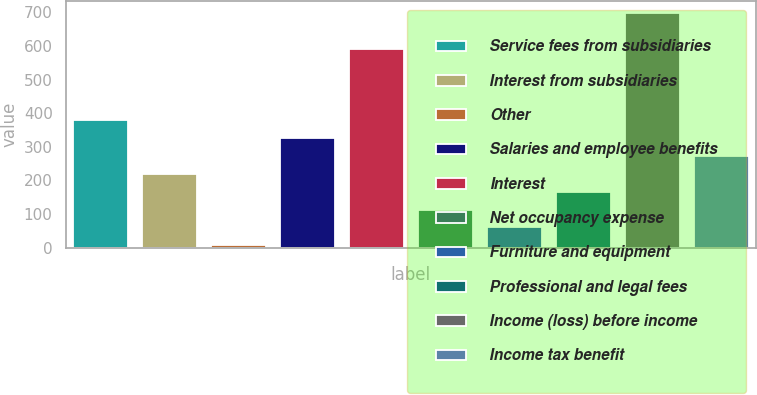Convert chart to OTSL. <chart><loc_0><loc_0><loc_500><loc_500><bar_chart><fcel>Service fees from subsidiaries<fcel>Interest from subsidiaries<fcel>Other<fcel>Salaries and employee benefits<fcel>Interest<fcel>Net occupancy expense<fcel>Furniture and equipment<fcel>Professional and legal fees<fcel>Income (loss) before income<fcel>Income tax benefit<nl><fcel>379.4<fcel>219.8<fcel>7<fcel>326.2<fcel>592.2<fcel>113.4<fcel>60.2<fcel>166.6<fcel>698.6<fcel>273<nl></chart> 